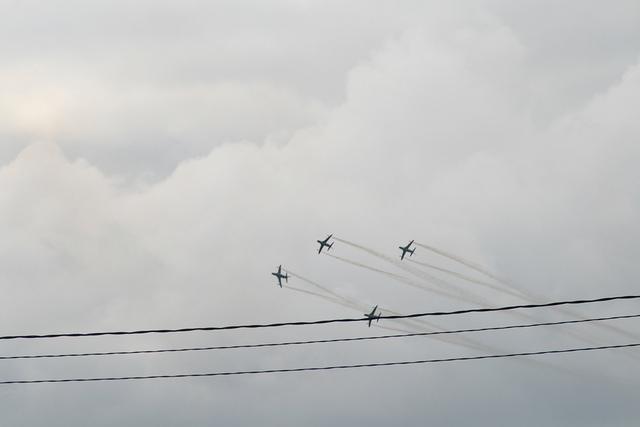How many planes are here?
Give a very brief answer. 4. How many people are wearing hats in the image?
Give a very brief answer. 0. 